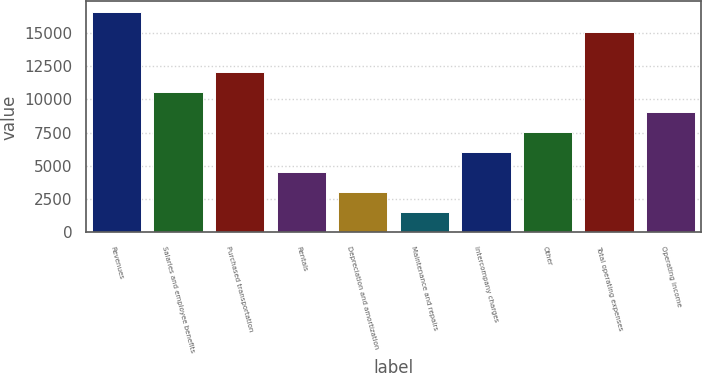<chart> <loc_0><loc_0><loc_500><loc_500><bar_chart><fcel>Revenues<fcel>Salaries and employee benefits<fcel>Purchased transportation<fcel>Rentals<fcel>Depreciation and amortization<fcel>Maintenance and repairs<fcel>Intercompany charges<fcel>Other<fcel>Total operating expenses<fcel>Operating income<nl><fcel>16555.3<fcel>10538<fcel>12042.4<fcel>4520.76<fcel>3016.44<fcel>1512.12<fcel>6025.08<fcel>7529.4<fcel>15051<fcel>9033.72<nl></chart> 